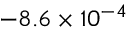<formula> <loc_0><loc_0><loc_500><loc_500>- 8 . 6 \times 1 0 ^ { - 4 }</formula> 